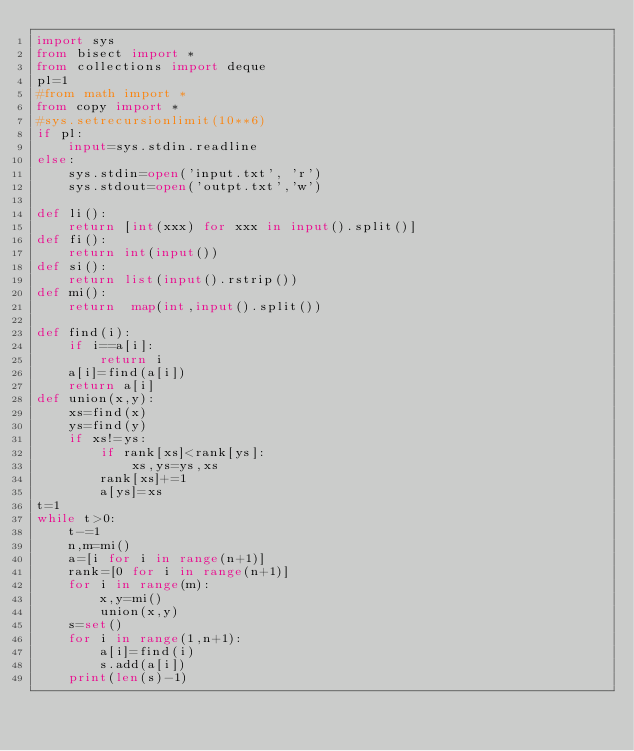<code> <loc_0><loc_0><loc_500><loc_500><_Python_>import sys
from bisect import *
from collections import deque
pl=1
#from math import *
from copy import *
#sys.setrecursionlimit(10**6)
if pl:
	input=sys.stdin.readline
else:	
	sys.stdin=open('input.txt', 'r')
	sys.stdout=open('outpt.txt','w')

def li():
	return [int(xxx) for xxx in input().split()]
def fi():
	return int(input())
def si():
	return list(input().rstrip())	
def mi():
	return 	map(int,input().split())	

def find(i):
	if i==a[i]:
		return i
	a[i]=find(a[i])
	return a[i]
def union(x,y):
	xs=find(x)
	ys=find(y)
	if xs!=ys:
		if rank[xs]<rank[ys]:
			xs,ys=ys,xs
		rank[xs]+=1
		a[ys]=xs		
t=1
while t>0:
	t-=1
	n,m=mi()
	a=[i for i in range(n+1)]	
	rank=[0 for i in range(n+1)]			
	for i in range(m):
		x,y=mi()
		union(x,y) 
	s=set()	
	for i in range(1,n+1):
		a[i]=find(i)
		s.add(a[i])
	print(len(s)-1)	


</code> 